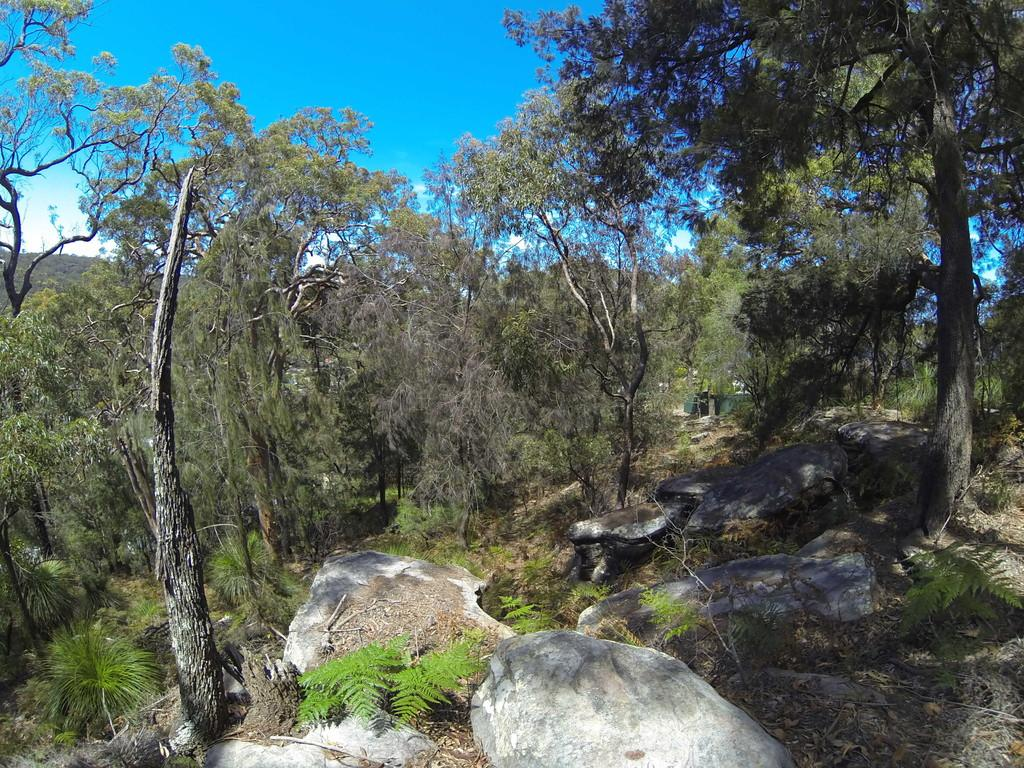What type of natural elements can be seen in the image? There are rocks and trees in the image. What is the color of the sky in the image? The sky is blue in color. Can you hear the wren talking to the rocks in the image? There is no wren or talking present in the image; it only features rocks, trees, and a blue sky. 